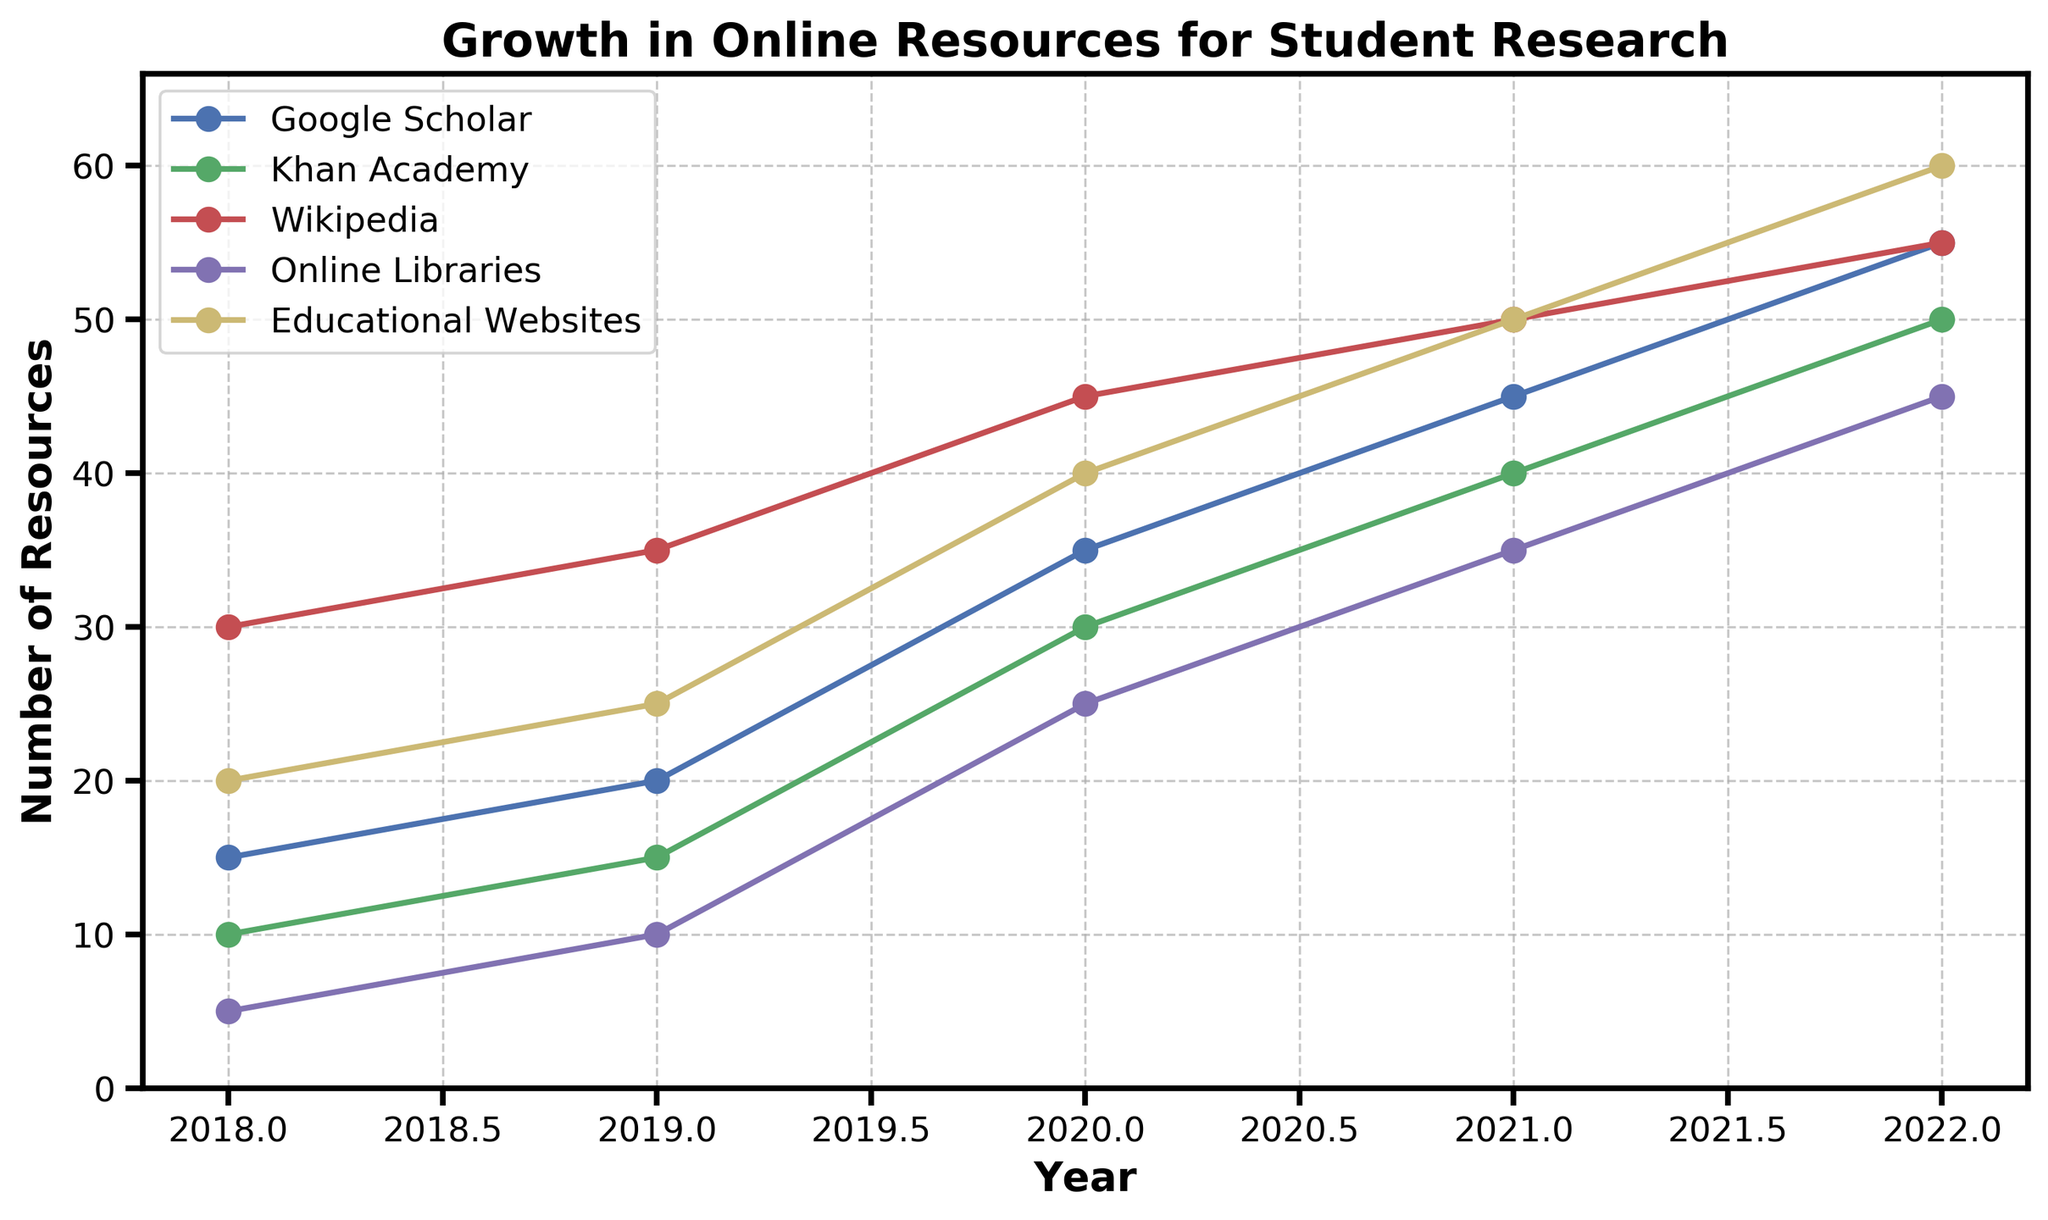What is the trend of the number of resources accessed from Google Scholar over the 5 years? The chart shows an increasing trend for Google Scholar. Starting from 15 in 2018, the number of resources accessed rises consistently each year, reaching 55 in 2022.
Answer: Increasing Which year saw the highest access of resources from Khan Academy? By examining the line representing Khan Academy, the highest point is in 2022, with 50 resources accessed.
Answer: 2022 How does the number of resources accessed from Wikipedia in 2020 compare to 2022? The number of resources accessed from Wikipedia in 2020 is 45, and in 2022 it is 55. Comparing these, 55 is greater than 45.
Answer: More in 2022 What is the average number of resources accessed from Online Libraries over the 5 years? Adding the numbers for each year (5 + 10 + 25 + 35 + 45) gives 120, and dividing by 5 years gives an average of 24.
Answer: 24 Which resource saw the most significant increase in the number of resources accessed between 2018 and 2022? Google Scholar increased from 15 to 55 (increase of 40), Khan Academy from 10 to 50 (increase of 40), Wikipedia from 30 to 55 (increase of 25), Online Libraries from 5 to 45 (increase of 40), and Educational Websites from 20 to 60 (increase of 40). Each of these resources has an equal maximum increase of 40.
Answer: Google Scholar, Khan Academy, Online Libraries, and Educational Websites What is the combined total of resources accessed from all sources in 2021? Summing up the values from all sources in 2021: Google Scholar (45) + Khan Academy (40) + Wikipedia (50) + Online Libraries (35) + Educational Websites (50) results in a total of 220.
Answer: 220 In which year did Educational Websites surpass Khan Academy in terms of the number of resources accessed? Examining the lines, Educational Websites exceed Khan Academy starting from 2021 (35 for Khan Academy vs. 45 for Educational Websites).
Answer: 2021 How much did the number of resources accessed from Online Libraries increase from 2019 to 2020? The number of resources accessed from Online Libraries in 2019 was 10 and in 2020 it was 25. The increase is 25 - 10 = 15.
Answer: 15 Among the five resources, which has the highest number of resources accessed in any single year and what is that value? Observing the highest point of all lines, Educational Websites reached 60 in 2022, which is the highest value in any given year.
Answer: Educational Websites, 60 